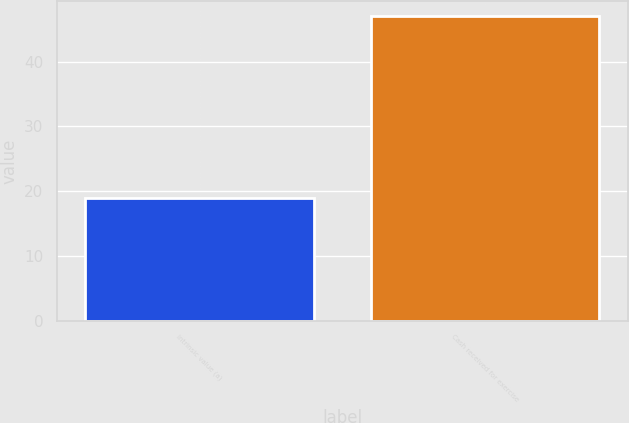Convert chart. <chart><loc_0><loc_0><loc_500><loc_500><bar_chart><fcel>Intrinsic value (a)<fcel>Cash received for exercise<nl><fcel>19<fcel>47<nl></chart> 